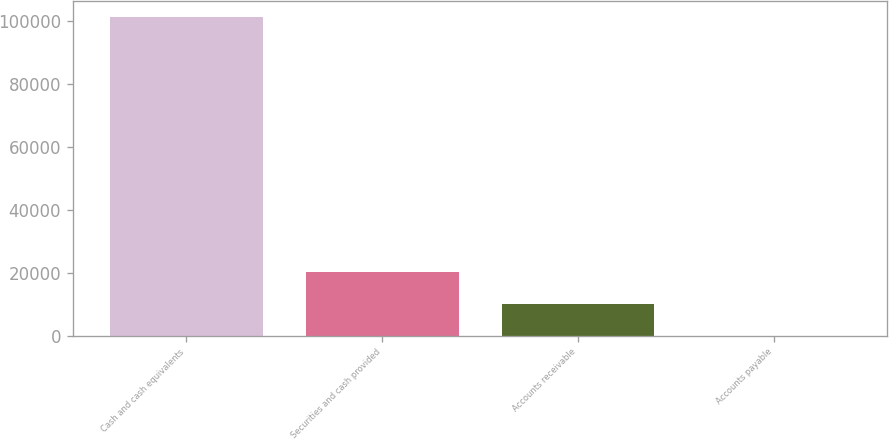Convert chart. <chart><loc_0><loc_0><loc_500><loc_500><bar_chart><fcel>Cash and cash equivalents<fcel>Securities and cash provided<fcel>Accounts receivable<fcel>Accounts payable<nl><fcel>101273<fcel>20277.8<fcel>10153.4<fcel>29<nl></chart> 